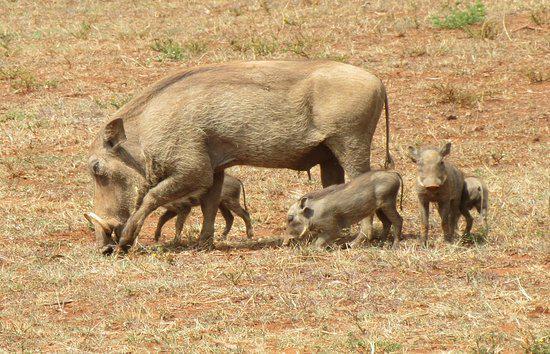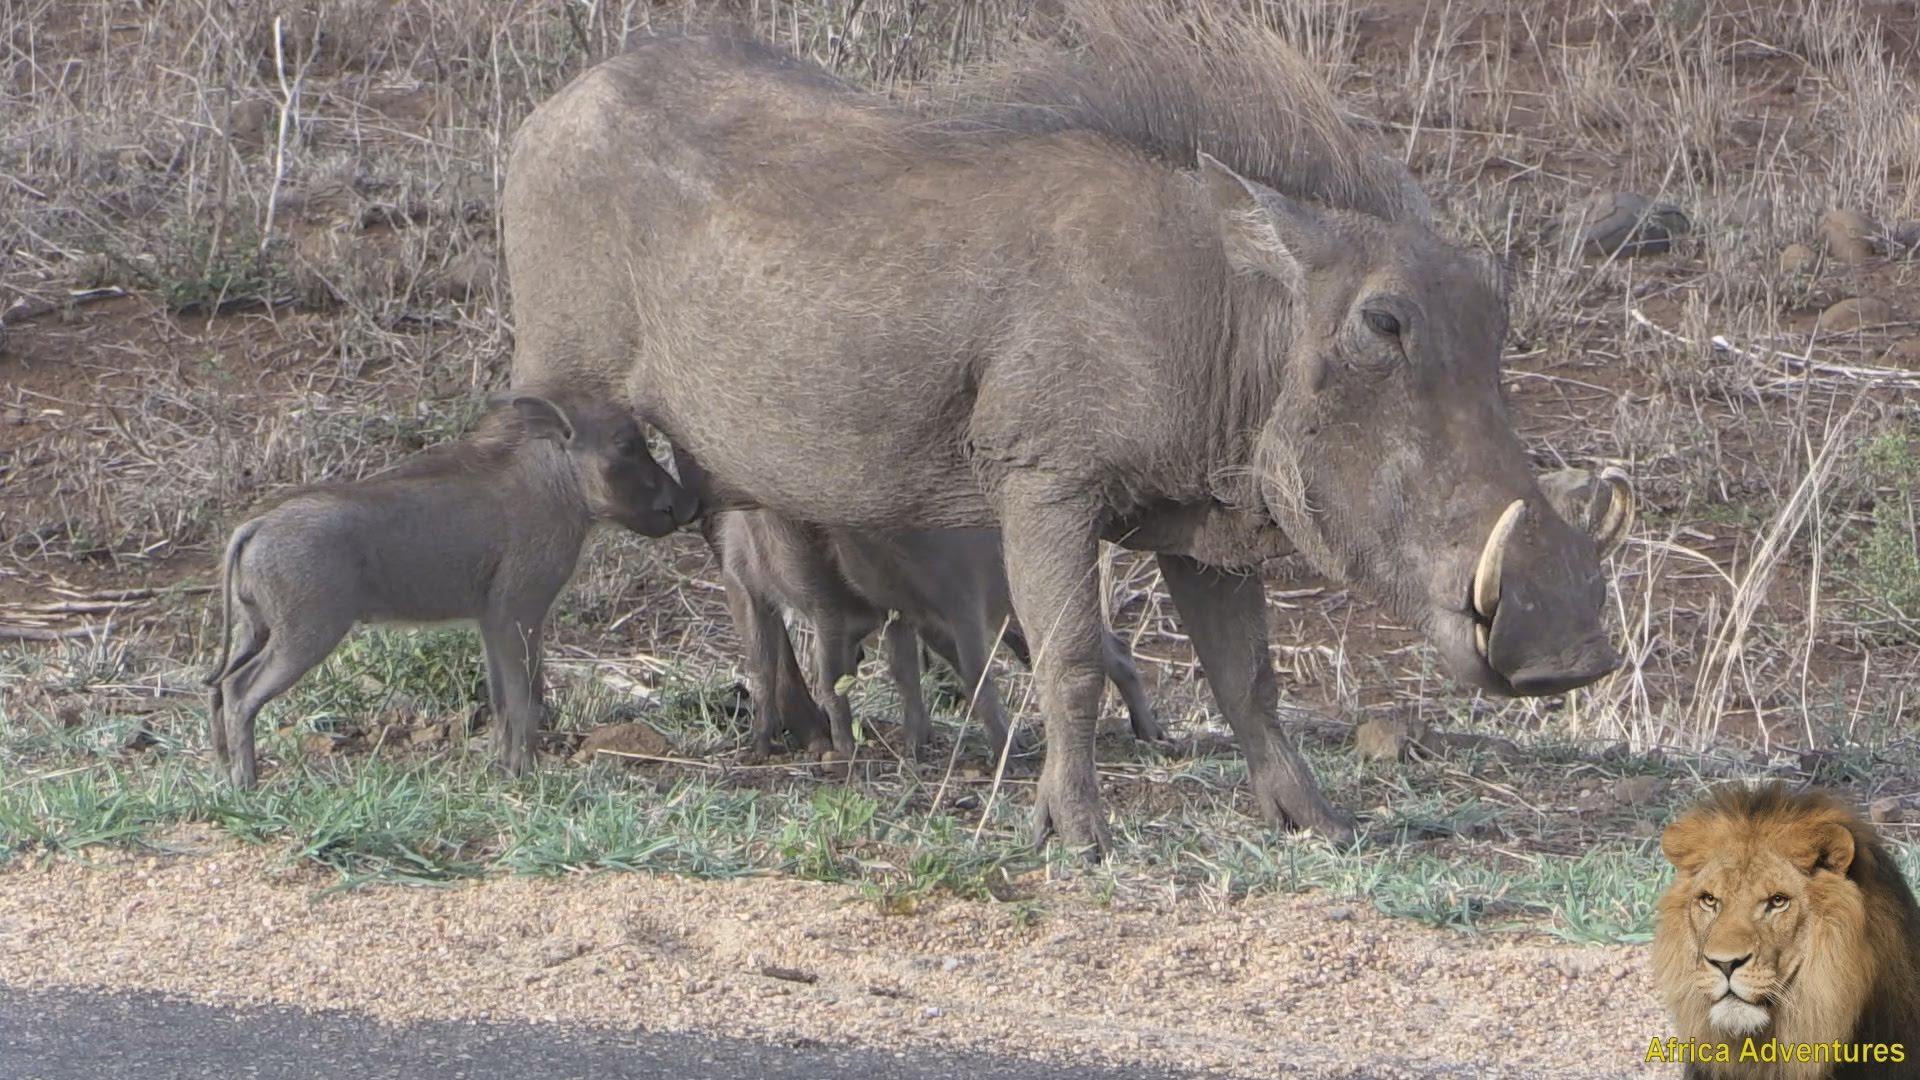The first image is the image on the left, the second image is the image on the right. Assess this claim about the two images: "An image includes multiple piglets with an adult warthog standing in profile facing leftward.". Correct or not? Answer yes or no. Yes. The first image is the image on the left, the second image is the image on the right. Assess this claim about the two images: "An image contains a cheetah attacking a wart hog.". Correct or not? Answer yes or no. No. 